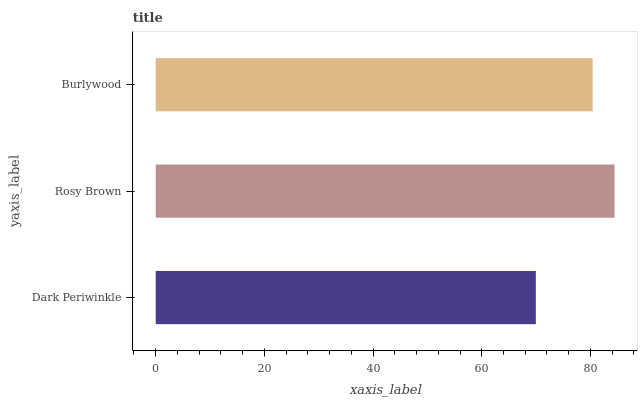Is Dark Periwinkle the minimum?
Answer yes or no. Yes. Is Rosy Brown the maximum?
Answer yes or no. Yes. Is Burlywood the minimum?
Answer yes or no. No. Is Burlywood the maximum?
Answer yes or no. No. Is Rosy Brown greater than Burlywood?
Answer yes or no. Yes. Is Burlywood less than Rosy Brown?
Answer yes or no. Yes. Is Burlywood greater than Rosy Brown?
Answer yes or no. No. Is Rosy Brown less than Burlywood?
Answer yes or no. No. Is Burlywood the high median?
Answer yes or no. Yes. Is Burlywood the low median?
Answer yes or no. Yes. Is Rosy Brown the high median?
Answer yes or no. No. Is Dark Periwinkle the low median?
Answer yes or no. No. 